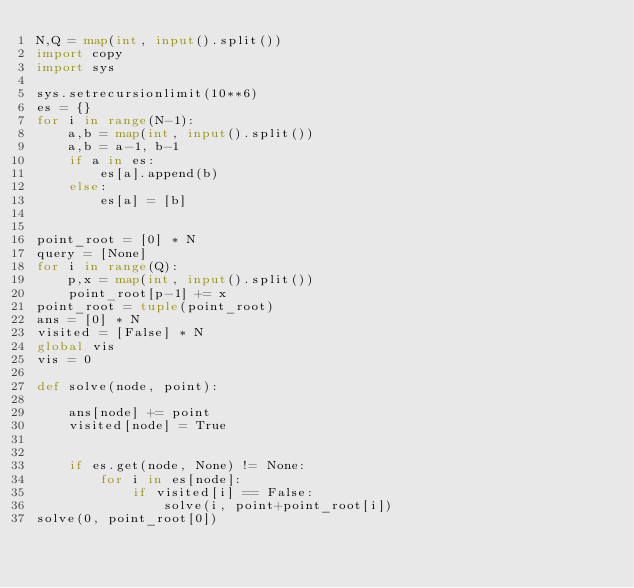<code> <loc_0><loc_0><loc_500><loc_500><_Python_>N,Q = map(int, input().split())
import copy
import sys

sys.setrecursionlimit(10**6)
es = {}
for i in range(N-1):
    a,b = map(int, input().split())
    a,b = a-1, b-1
    if a in es:
        es[a].append(b)
    else:
        es[a] = [b]


point_root = [0] * N
query = [None]
for i in range(Q):
    p,x = map(int, input().split())
    point_root[p-1] += x 
point_root = tuple(point_root)
ans = [0] * N
visited = [False] * N
global vis
vis = 0

def solve(node, point):
    
    ans[node] += point
    visited[node] = True


    if es.get(node, None) != None:
        for i in es[node]:
            if visited[i] == False:
                solve(i, point+point_root[i])
solve(0, point_root[0])</code> 